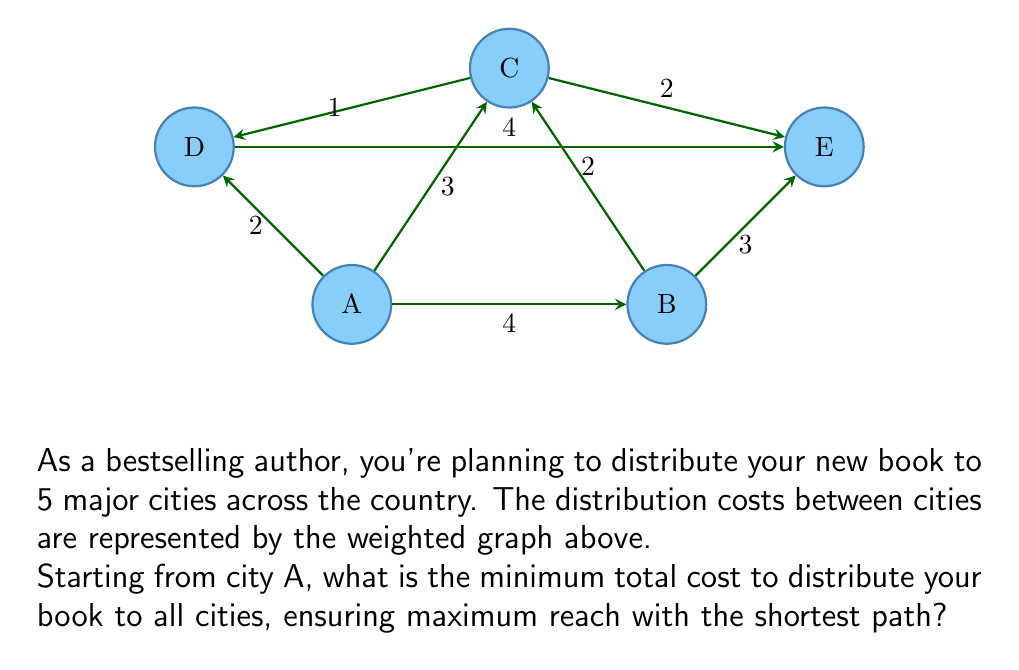Could you help me with this problem? To solve this problem, we need to find the minimum spanning tree (MST) of the given graph. The MST will give us the shortest path that connects all cities with the minimum total cost. We'll use Kruskal's algorithm to find the MST:

1) Sort all edges by weight in ascending order:
   C-D (1), A-D (2), B-C (2), C-E (2), A-C (3), B-E (3), A-B (4), D-E (4)

2) Start with an empty set of edges and add edges one by one, skipping those that would create a cycle:

   - Add C-D (1)
   - Add A-D (2)
   - Add B-C (2)
   - Add C-E (2)

3) At this point, we have connected all vertices with 4 edges, so we stop.

4) The resulting MST is:
   A-D (2) + C-D (1) + B-C (2) + C-E (2)

5) Calculate the total cost:
   $$ \text{Total Cost} = 2 + 1 + 2 + 2 = 7 $$

Therefore, the minimum total cost to distribute the book to all cities, starting from city A, is 7.
Answer: 7 